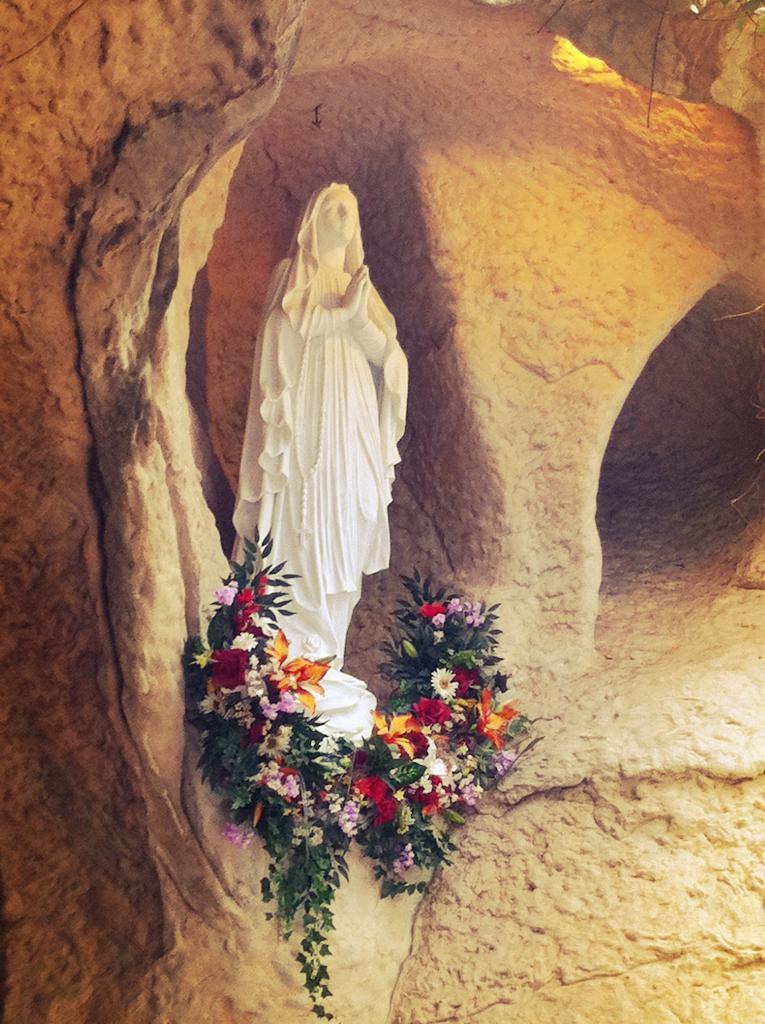Could you give a brief overview of what you see in this image? As we can see in the image there is a statue and flowers. 